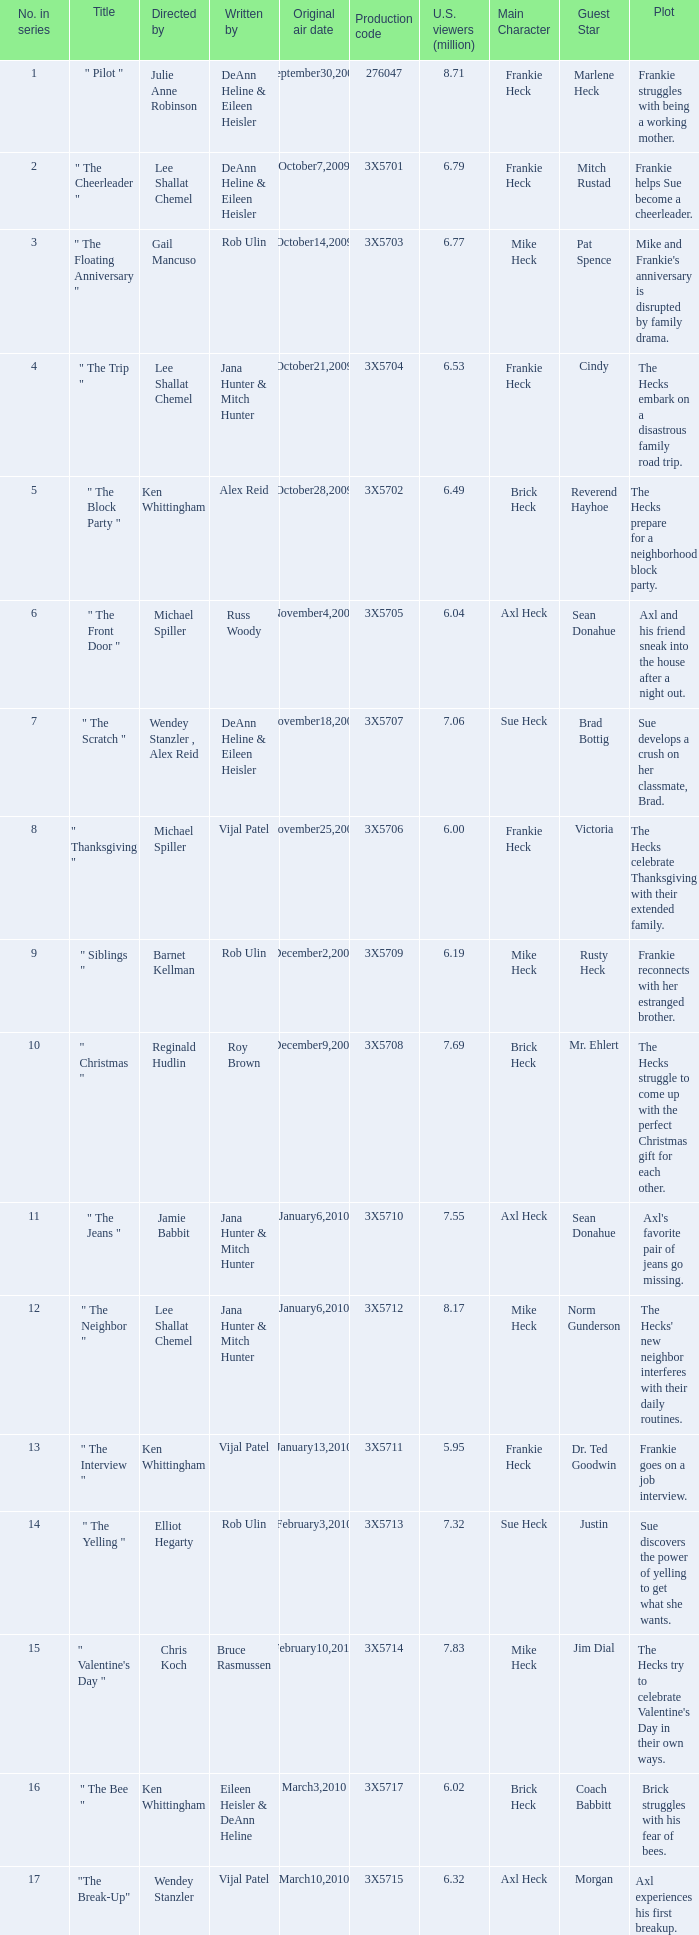For the episode with production code 3x5710, how many u.s. viewers in millions tuned in? 7.55. 